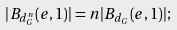Convert formula to latex. <formula><loc_0><loc_0><loc_500><loc_500>| B _ { d _ { G } ^ { n } } ( e , 1 ) | = n | B _ { d _ { G } } ( e , 1 ) | ;</formula> 